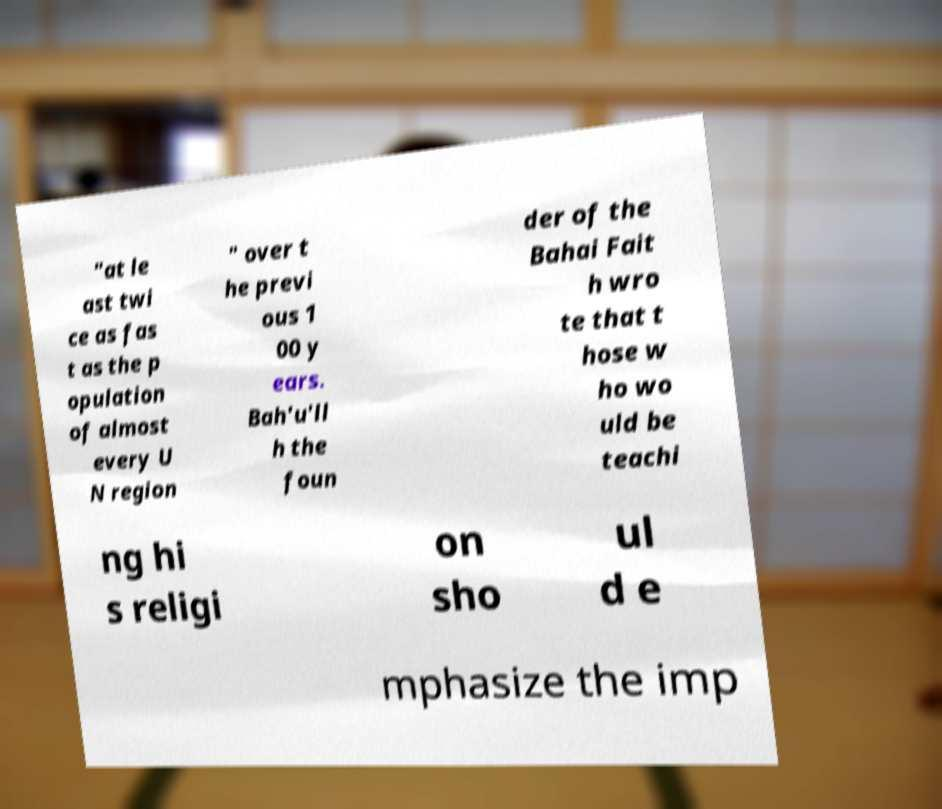Please read and relay the text visible in this image. What does it say? "at le ast twi ce as fas t as the p opulation of almost every U N region " over t he previ ous 1 00 y ears. Bah'u'll h the foun der of the Bahai Fait h wro te that t hose w ho wo uld be teachi ng hi s religi on sho ul d e mphasize the imp 